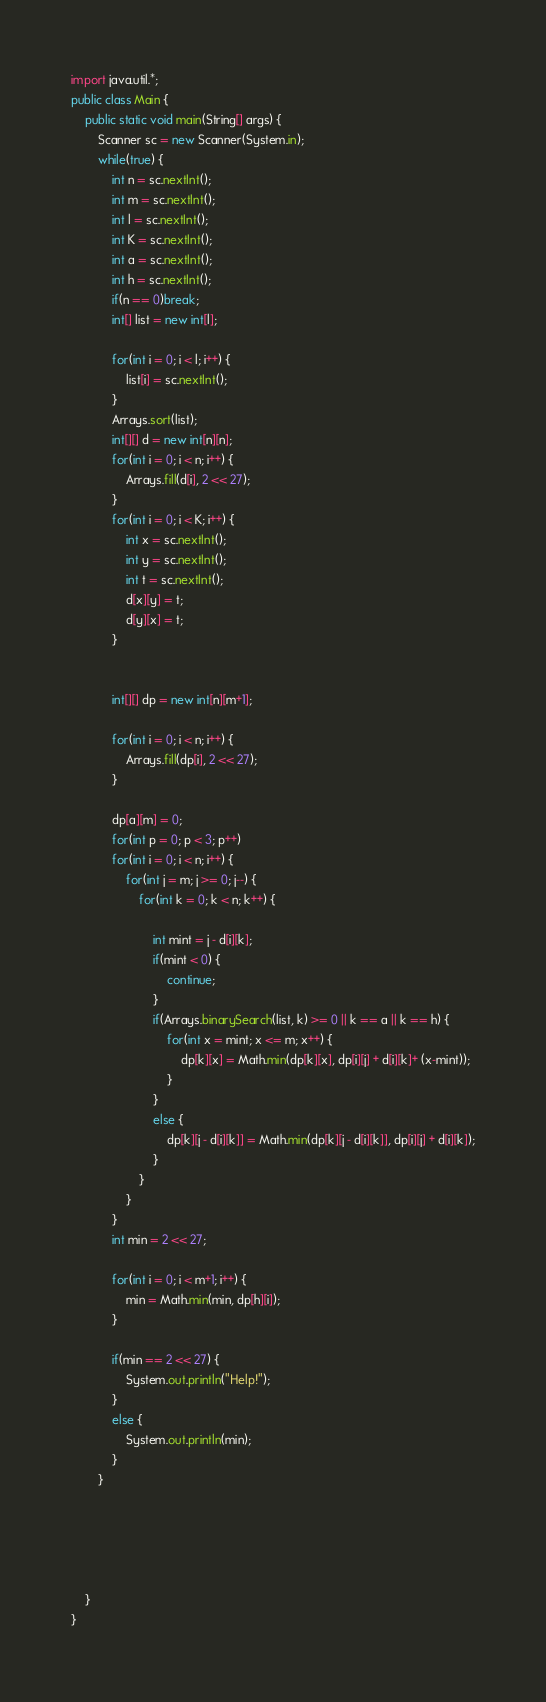Convert code to text. <code><loc_0><loc_0><loc_500><loc_500><_Java_>import java.util.*;
public class Main {
	public static void main(String[] args) {
		Scanner sc = new Scanner(System.in);
		while(true) {
			int n = sc.nextInt();
			int m = sc.nextInt();
			int l = sc.nextInt();
			int K = sc.nextInt();
			int a = sc.nextInt();
			int h = sc.nextInt();
			if(n == 0)break;
			int[] list = new int[l];
			
			for(int i = 0; i < l; i++) {
				list[i] = sc.nextInt();
			}
			Arrays.sort(list);
			int[][] d = new int[n][n];
			for(int i = 0; i < n; i++) {
				Arrays.fill(d[i], 2 << 27);
			}
			for(int i = 0; i < K; i++) {
				int x = sc.nextInt();
				int y = sc.nextInt();
				int t = sc.nextInt();
				d[x][y] = t;
				d[y][x] = t;
			}
			
			
			int[][] dp = new int[n][m+1];
			
			for(int i = 0; i < n; i++) {
				Arrays.fill(dp[i], 2 << 27);
			}
			
			dp[a][m] = 0;
			for(int p = 0; p < 3; p++)
			for(int i = 0; i < n; i++) {
				for(int j = m; j >= 0; j--) {
					for(int k = 0; k < n; k++) {
					
						int mint = j - d[i][k];
						if(mint < 0) {
							continue;
						}
						if(Arrays.binarySearch(list, k) >= 0 || k == a || k == h) {
							for(int x = mint; x <= m; x++) {
								dp[k][x] = Math.min(dp[k][x], dp[i][j] + d[i][k]+ (x-mint));
							}
						}
						else {
							dp[k][j - d[i][k]] = Math.min(dp[k][j - d[i][k]], dp[i][j] + d[i][k]);
						}
					}
				}
			}
			int min = 2 << 27;

			for(int i = 0; i < m+1; i++) {
				min = Math.min(min, dp[h][i]);
			}
			
			if(min == 2 << 27) {
				System.out.println("Help!");
			}
			else {
				System.out.println(min);
			}			
		}
		
		
		
		
		
	}
}                  </code> 